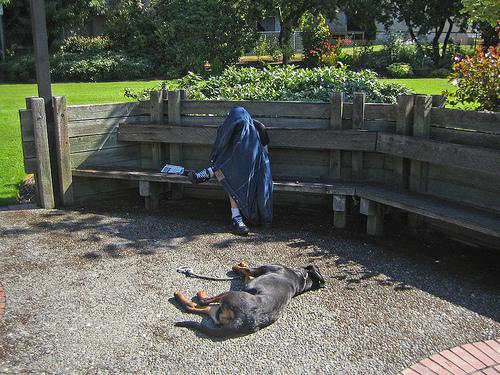What kind of fence can be seen in the image? There's a chain link fence on the other side of the trees. Explain the unusual position of a foot in the image. There's a person's foot in the air, as if they're about to step or in the middle of an action. Mention a notable feature of the dog's appearance. The dog's tail is a stub. Explain the appearance of the person sitting on the bench and their unusual accessory. The person is sitting on the bench with a denim jacket covering their head and body, and they have on black shoes. Mention the style of the jacket covering the person on the bench. The jacket covering the person on the bench is a jean jacket. Describe the color and material of the bench in the image. The bench is made of wood and has a long, wooden design. What type of plant can be spotted near the tree in the image? There are red flowers next to the tree. Describe the setting where the image takes place. The image takes place in a park with a field of bright green grass, trees behind benches, green plants growing over the bench, and a chain link fence in the background. What type of animal is on the ground in the image? A brown and black dog is lying on the ground. List three objects that can be seen in the image. A long wooden bench, a denim jacket, and a dog lying on the ground. 